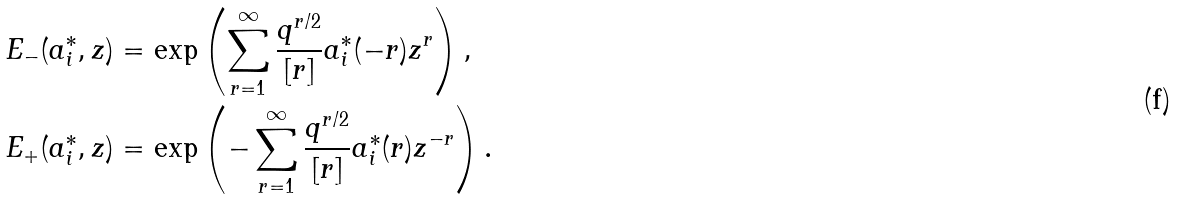Convert formula to latex. <formula><loc_0><loc_0><loc_500><loc_500>E _ { - } ( a _ { i } ^ { * } , z ) & = \exp \left ( \sum _ { r = 1 } ^ { \infty } \frac { q ^ { r / 2 } } { [ r ] } a _ { i } ^ { * } ( - r ) z ^ { r } \right ) , \\ E _ { + } ( a _ { i } ^ { * } , z ) & = \exp \left ( - \sum _ { r = 1 } ^ { \infty } \frac { q ^ { r / 2 } } { [ r ] } a _ { i } ^ { * } ( r ) z ^ { - r } \right ) .</formula> 